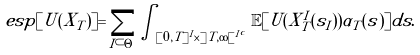<formula> <loc_0><loc_0><loc_500><loc_500>\ e s p [ U ( X _ { T } ) ] = \sum _ { I \subset \Theta } \int _ { [ 0 , T ] ^ { I } \times ] T , \infty [ ^ { I ^ { c } } } \mathbb { E } [ U ( X _ { T } ^ { I } ( s _ { I } ) ) \alpha _ { T } ( s ) ] d s .</formula> 